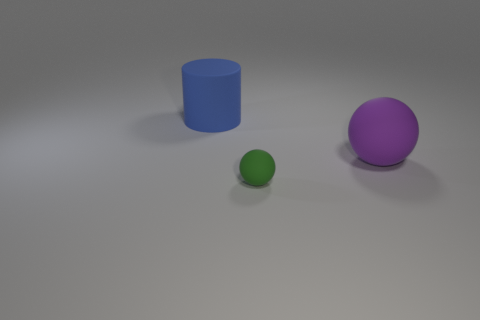Are there any other things that have the same shape as the big blue thing?
Make the answer very short. No. There is another thing that is the same size as the blue rubber object; what is it made of?
Offer a terse response. Rubber. How many other objects are the same material as the blue thing?
Your answer should be very brief. 2. There is a big rubber object in front of the blue matte thing; is its shape the same as the large matte thing that is behind the purple ball?
Make the answer very short. No. Does the sphere that is behind the small green object have the same material as the object in front of the large ball?
Ensure brevity in your answer.  Yes. Are there the same number of purple things that are on the left side of the blue object and big blue objects that are on the left side of the tiny green rubber thing?
Keep it short and to the point. No. Is there any other thing that is the same size as the green matte object?
Provide a short and direct response. No. Are there fewer large purple balls than brown objects?
Give a very brief answer. No. There is a matte object that is both behind the small green ball and on the left side of the big purple object; what shape is it?
Offer a terse response. Cylinder. What number of things are there?
Keep it short and to the point. 3. 